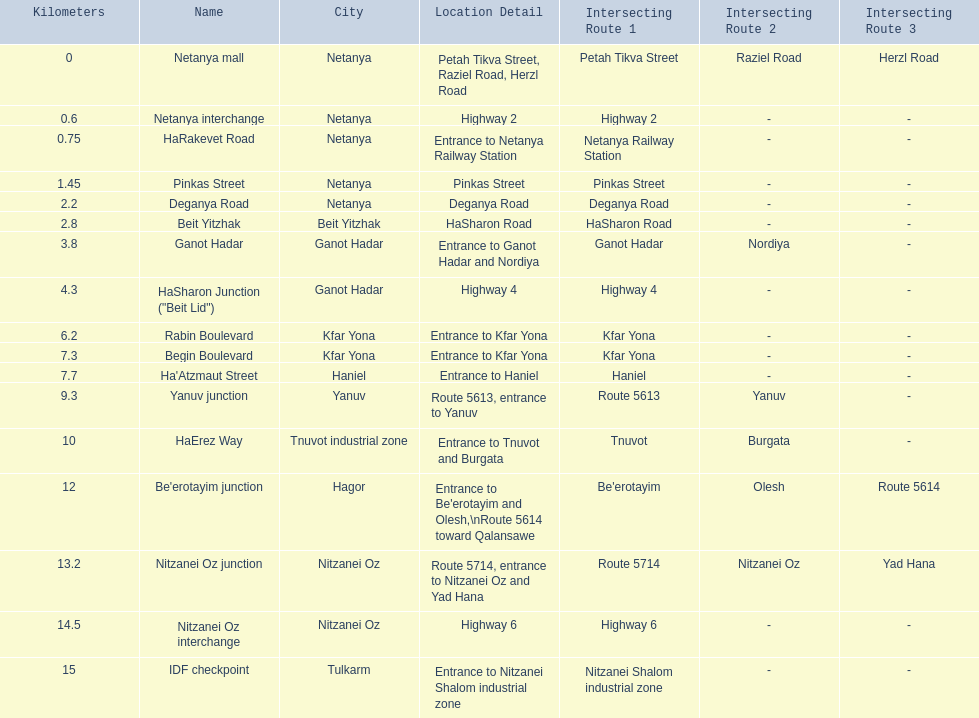What are all of the different portions? Netanya mall, Netanya interchange, HaRakevet Road, Pinkas Street, Deganya Road, Beit Yitzhak, Ganot Hadar, HaSharon Junction ("Beit Lid"), Rabin Boulevard, Begin Boulevard, Ha'Atzmaut Street, Yanuv junction, HaErez Way, Be'erotayim junction, Nitzanei Oz junction, Nitzanei Oz interchange, IDF checkpoint. What is the intersecting route for rabin boulevard? Entrance to Kfar Yona. What portion also has an intersecting route of entrance to kfar yona? Begin Boulevard. 